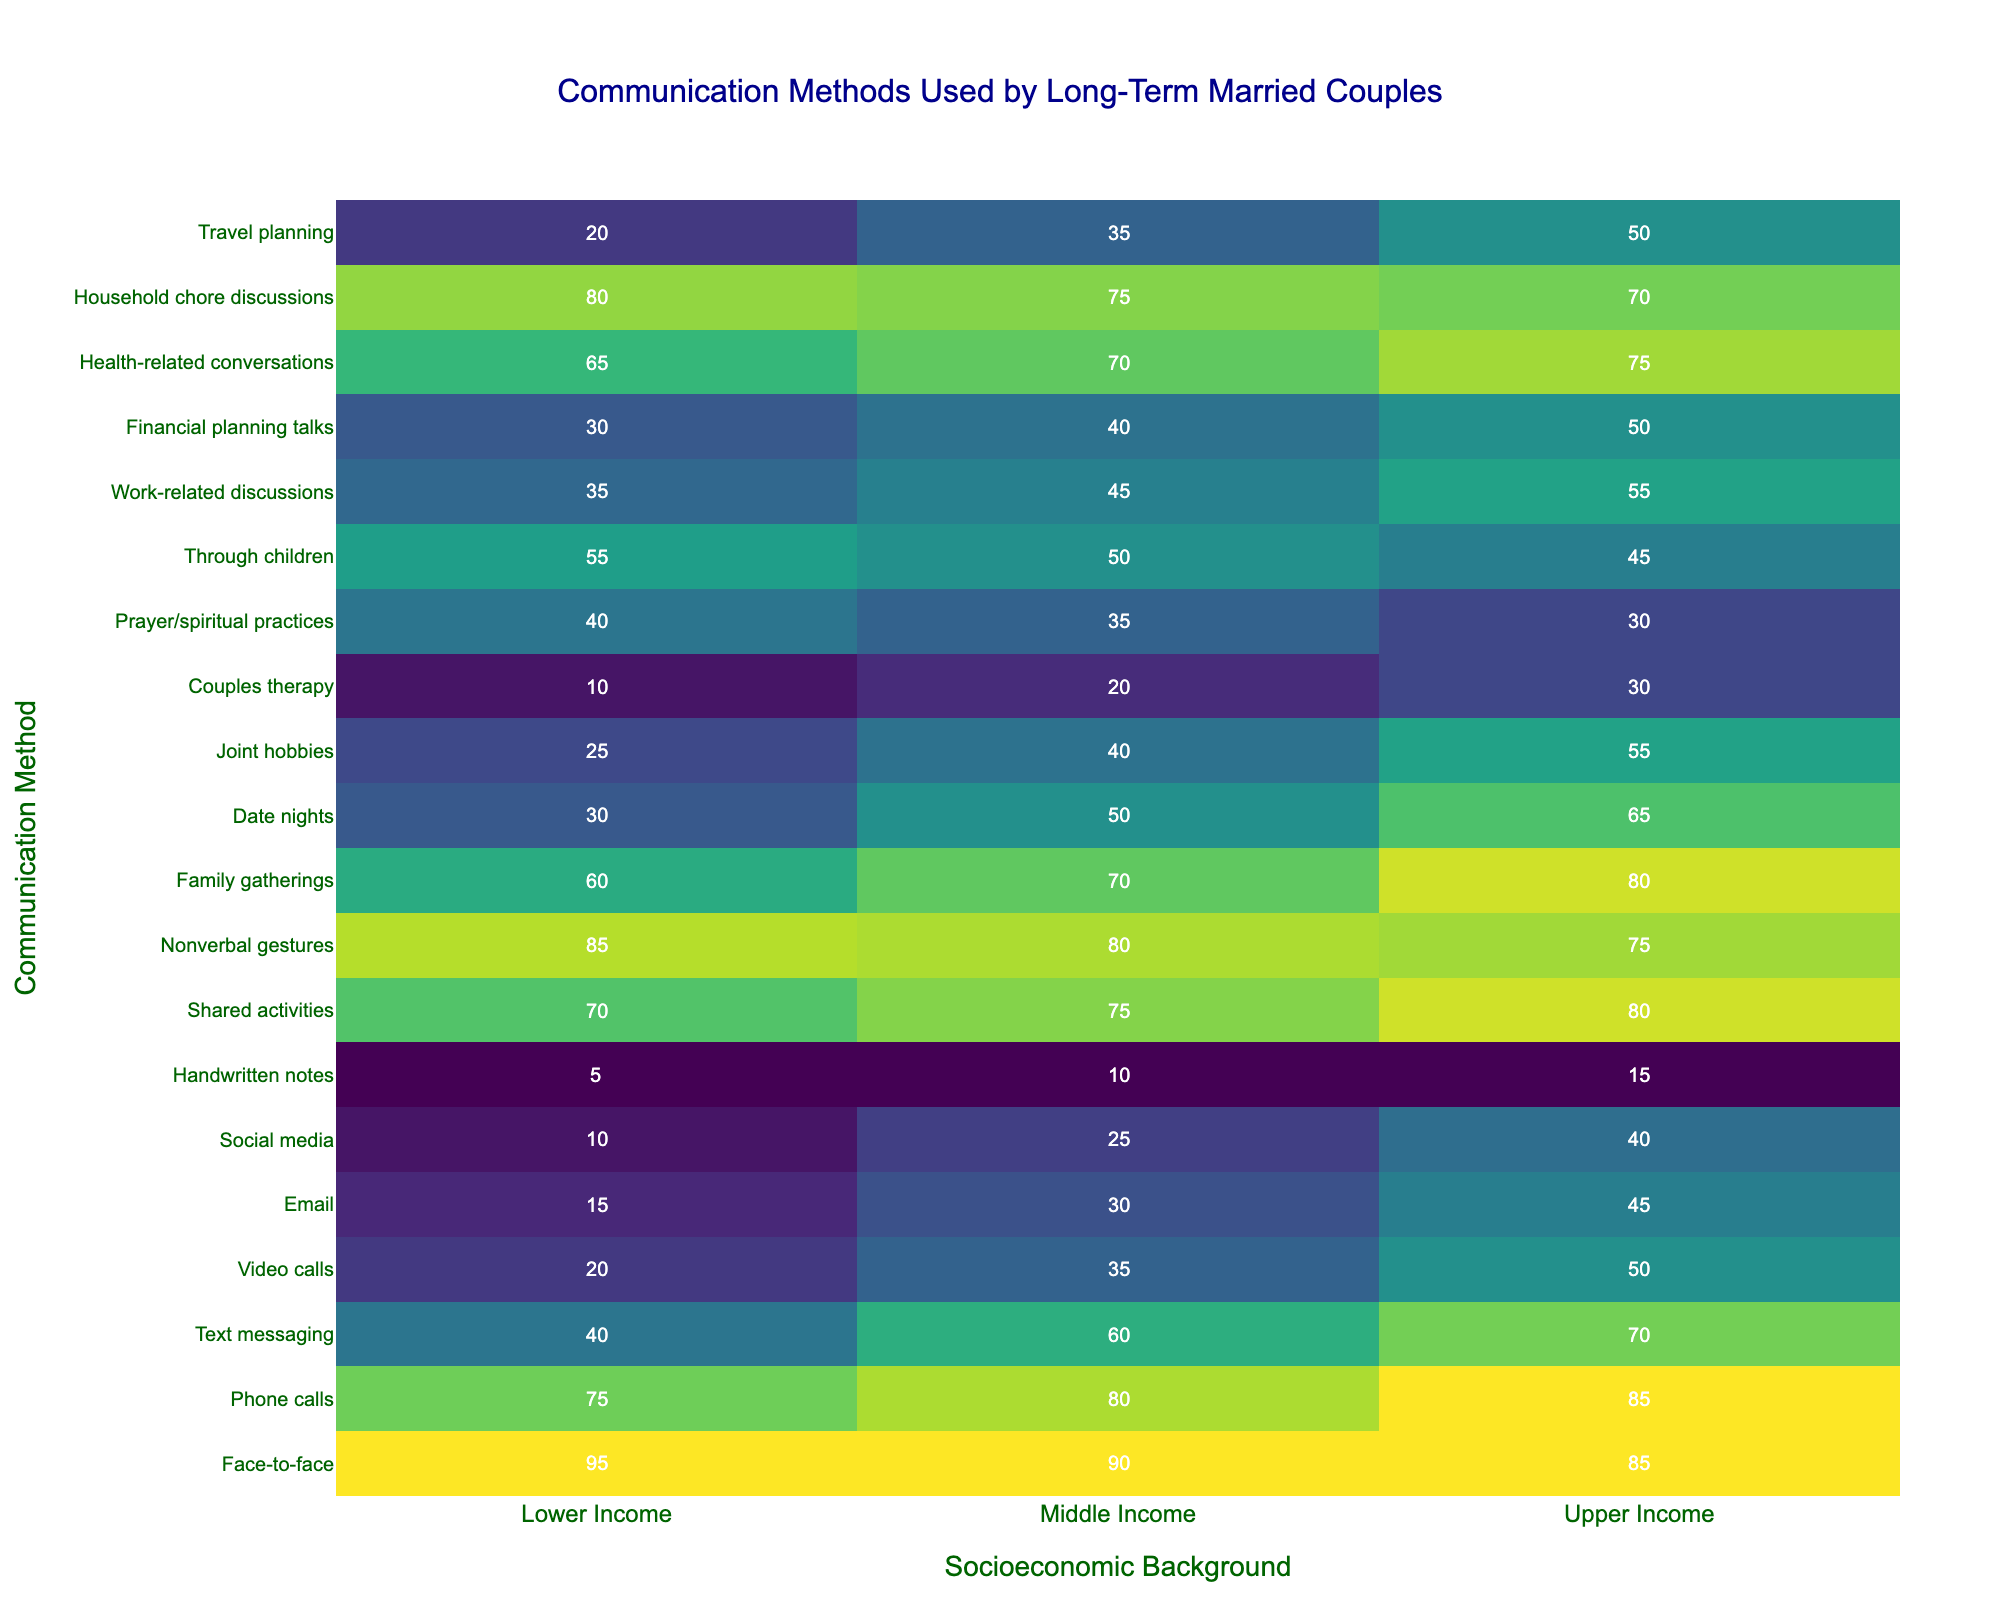What is the most frequently used communication method among lower-income couples? The table shows that the communication method used by 95% of lower-income couples is face-to-face.
Answer: Face-to-face Which socioeconomic group uses video calls the most? Lower-income couples use video calls the least (20%), while upper-income couples use them the most (50%).
Answer: Upper income Is texting more or less common among middle-income couples compared to lower-income couples? Middle-income couples use texting at 60%, which is more than the 40% usage among lower-income couples.
Answer: More What is the difference in percentage points for using handwritten notes between lower-income and upper-income couples? Lower-income couples use handwritten notes at 5%, while upper-income couples use them at 15%. The difference is 15% - 5% = 10%.
Answer: 10 What is the average percentage of couples using health-related conversations across all socioeconomic backgrounds? The percentages are 65% (lower), 70% (middle), and 75% (upper). The average is (65 + 70 + 75) / 3 = 210 / 3 = 70.
Answer: 70 Which communication method shows the greatest disparity between the lower-income and upper-income groups? The communication method "Face-to-face" shows the greatest disparity: 95% for lower-income vs. 85% for upper-income, a difference of 10%.
Answer: Face-to-face Do upper-income couples engage in family gatherings more often than lower-income couples? Yes, upper-income couples engage in family gatherings at 80%, while lower-income couples only do at 60%.
Answer: Yes What percentage of middle-income couples use text messaging and how does it compare to the percentage of lower-income couples? Middle-income couples use text messaging at 60%, while lower-income couples use it at 40%. The difference is 60% - 40% = 20%.
Answer: 20 Which socioeconomic group has the highest percentage of couples discussing financial planning? Upper-income couples have the highest percentage discussing financial planning at 50%.
Answer: Upper income How many communication methods have a higher usage rate in lower-income couples compared to upper-income couples? Analyzing the table, 8 communication methods have higher usage in lower-income couples compared to upper-income couples.
Answer: 8 